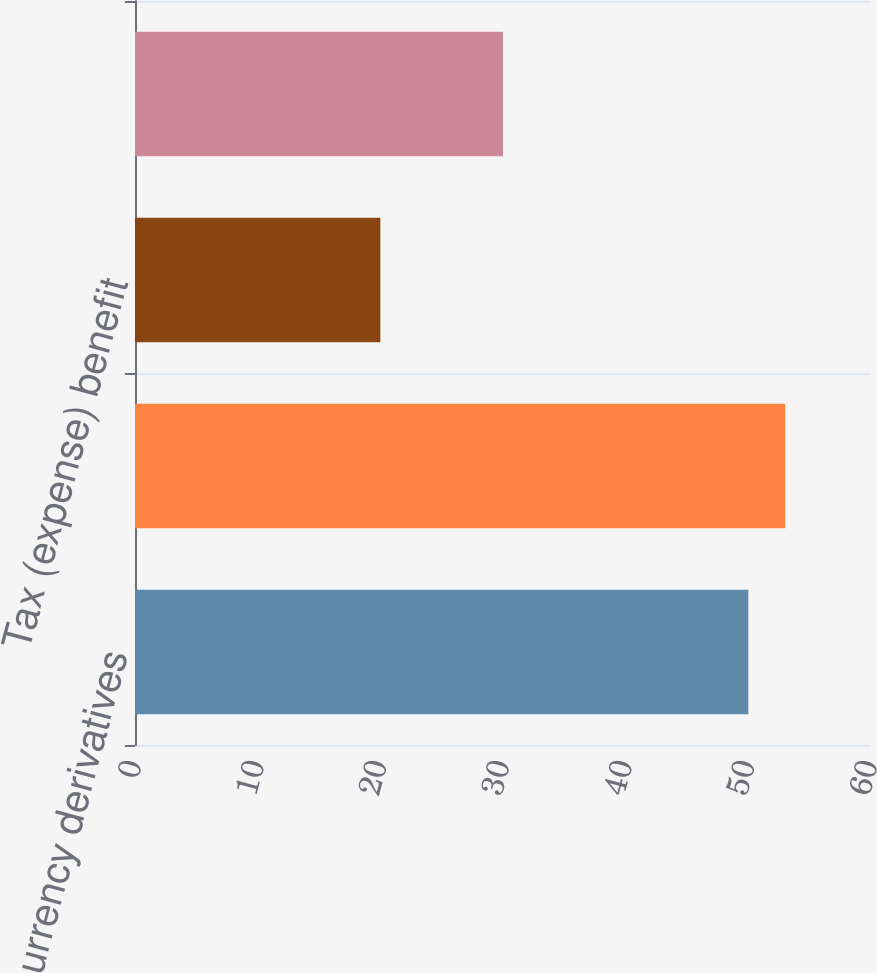Convert chart to OTSL. <chart><loc_0><loc_0><loc_500><loc_500><bar_chart><fcel>Foreign currency derivatives<fcel>Total before tax<fcel>Tax (expense) benefit<fcel>Netoftax<nl><fcel>50<fcel>53<fcel>20<fcel>30<nl></chart> 